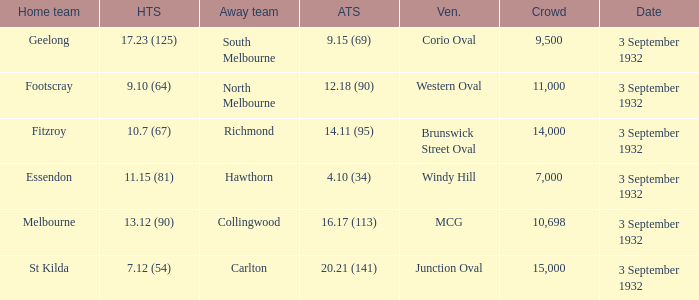What is the name of the Venue for the team that has an Away team score of 14.11 (95)? Brunswick Street Oval. 